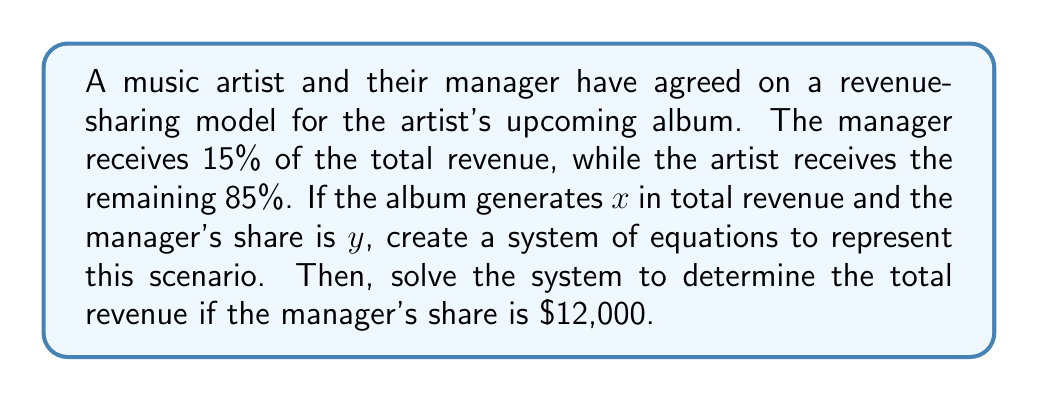Teach me how to tackle this problem. Let's approach this step-by-step:

1) First, we need to set up our system of equations based on the given information:

   Equation 1: The manager's share is 15% of the total revenue
   $$ y = 0.15x $$

   Equation 2: The artist's share plus the manager's share equals the total revenue
   $$ 0.85x + y = x $$

2) Now we have our system of equations:
   $$
   \begin{cases}
   y = 0.15x \\
   0.85x + y = x
   \end{cases}
   $$

3) To solve this system, let's substitute the first equation into the second:
   $$ 0.85x + 0.15x = x $$

4) Simplify:
   $$ x = x $$

   This identity is always true, which means our equations are consistent but dependent. We need the additional information that the manager's share is $12,000 to find a unique solution.

5) Given that the manager's share (y) is $12,000, we can use the first equation:
   $$ 12000 = 0.15x $$

6) Solve for x:
   $$ x = \frac{12000}{0.15} = 80000 $$

Therefore, if the manager's share is $12,000, the total revenue must be $80,000.
Answer: The total revenue is $80,000. 